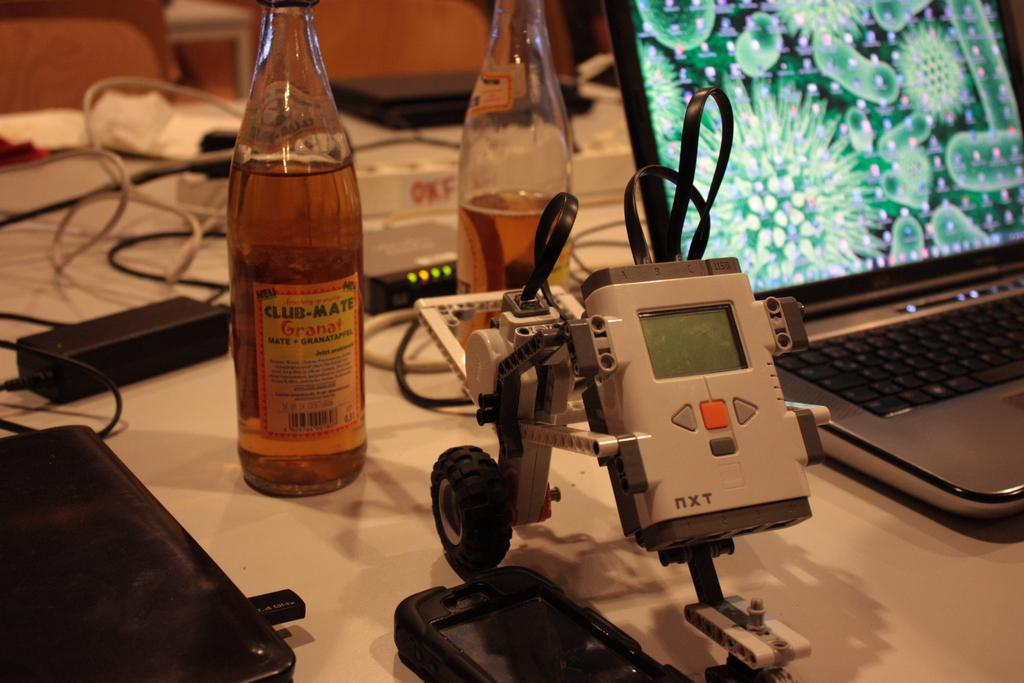What electronic device is visible in the image? There is a laptop in the image. What other electronic items can be seen in the image? There is electrical equipment in the image. What type of containers are present in the image? There are bottles in the image. What is used to power the laptop in the image? There is a charger in the image. Where are all these items located in the image? All of these items are on a table. What type of ball is being used to gain knowledge in the image? There is no ball present in the image, and no indication that knowledge is being gained through any physical activity. 